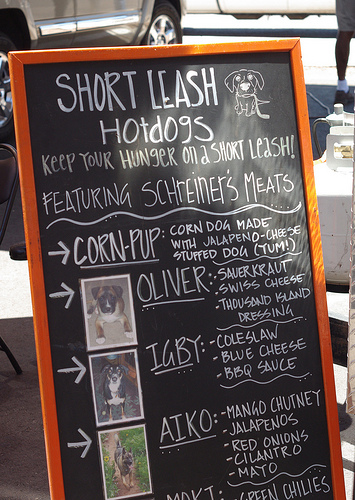<image>
Is there a photo next to the chalkboard? No. The photo is not positioned next to the chalkboard. They are located in different areas of the scene. Is the picture in the chalk board? No. The picture is not contained within the chalk board. These objects have a different spatial relationship. 